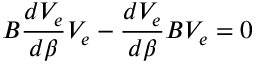<formula> <loc_0><loc_0><loc_500><loc_500>B \frac { d V _ { e } } { d \beta } V _ { e } - \frac { d V _ { e } } { d \beta } B V _ { e } = 0</formula> 